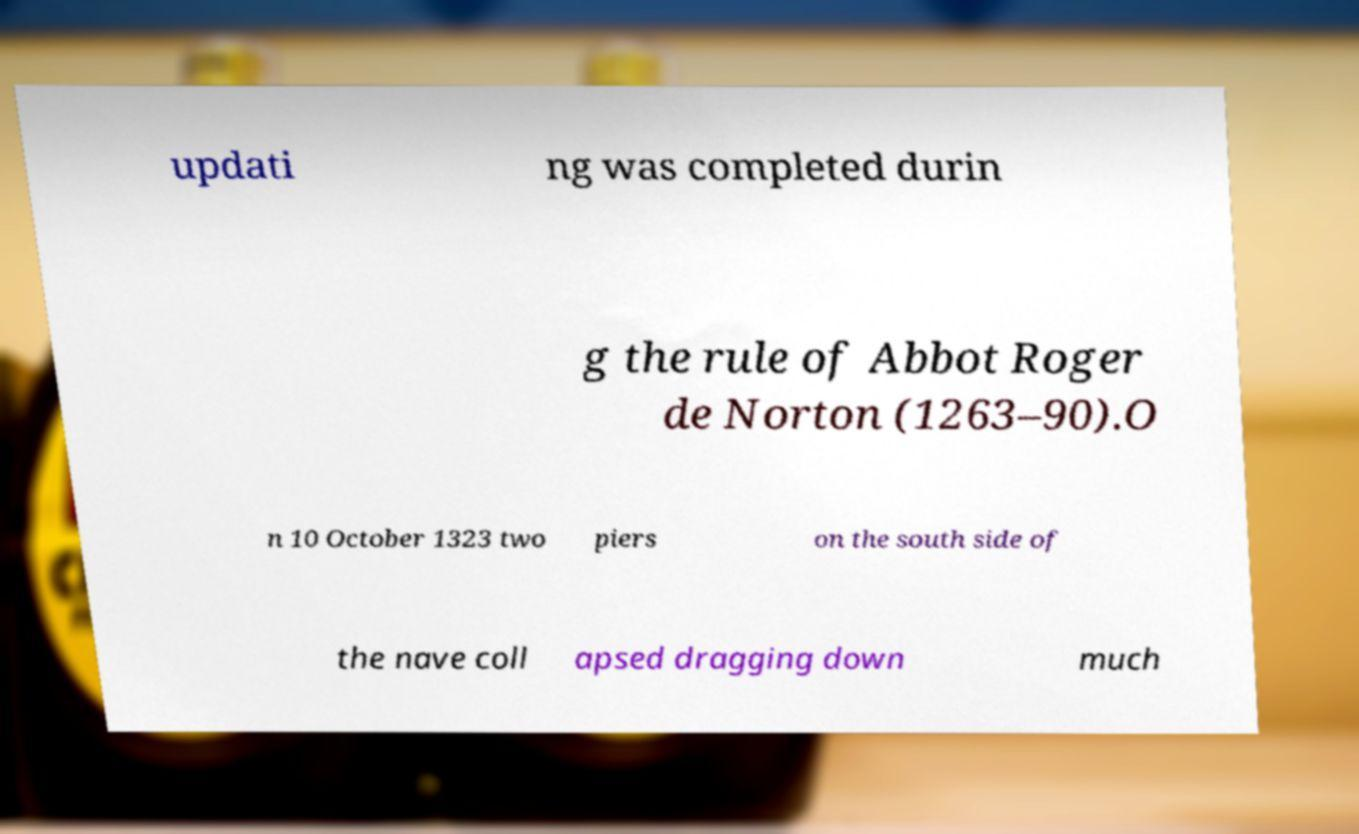Please identify and transcribe the text found in this image. updati ng was completed durin g the rule of Abbot Roger de Norton (1263–90).O n 10 October 1323 two piers on the south side of the nave coll apsed dragging down much 